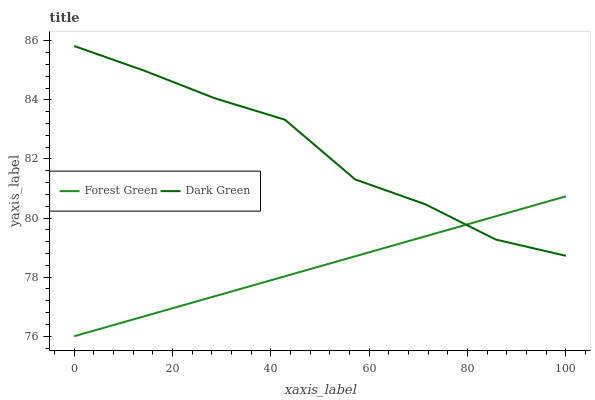Does Forest Green have the minimum area under the curve?
Answer yes or no. Yes. Does Dark Green have the maximum area under the curve?
Answer yes or no. Yes. Does Dark Green have the minimum area under the curve?
Answer yes or no. No. Is Forest Green the smoothest?
Answer yes or no. Yes. Is Dark Green the roughest?
Answer yes or no. Yes. Is Dark Green the smoothest?
Answer yes or no. No. Does Forest Green have the lowest value?
Answer yes or no. Yes. Does Dark Green have the lowest value?
Answer yes or no. No. Does Dark Green have the highest value?
Answer yes or no. Yes. Does Dark Green intersect Forest Green?
Answer yes or no. Yes. Is Dark Green less than Forest Green?
Answer yes or no. No. Is Dark Green greater than Forest Green?
Answer yes or no. No. 